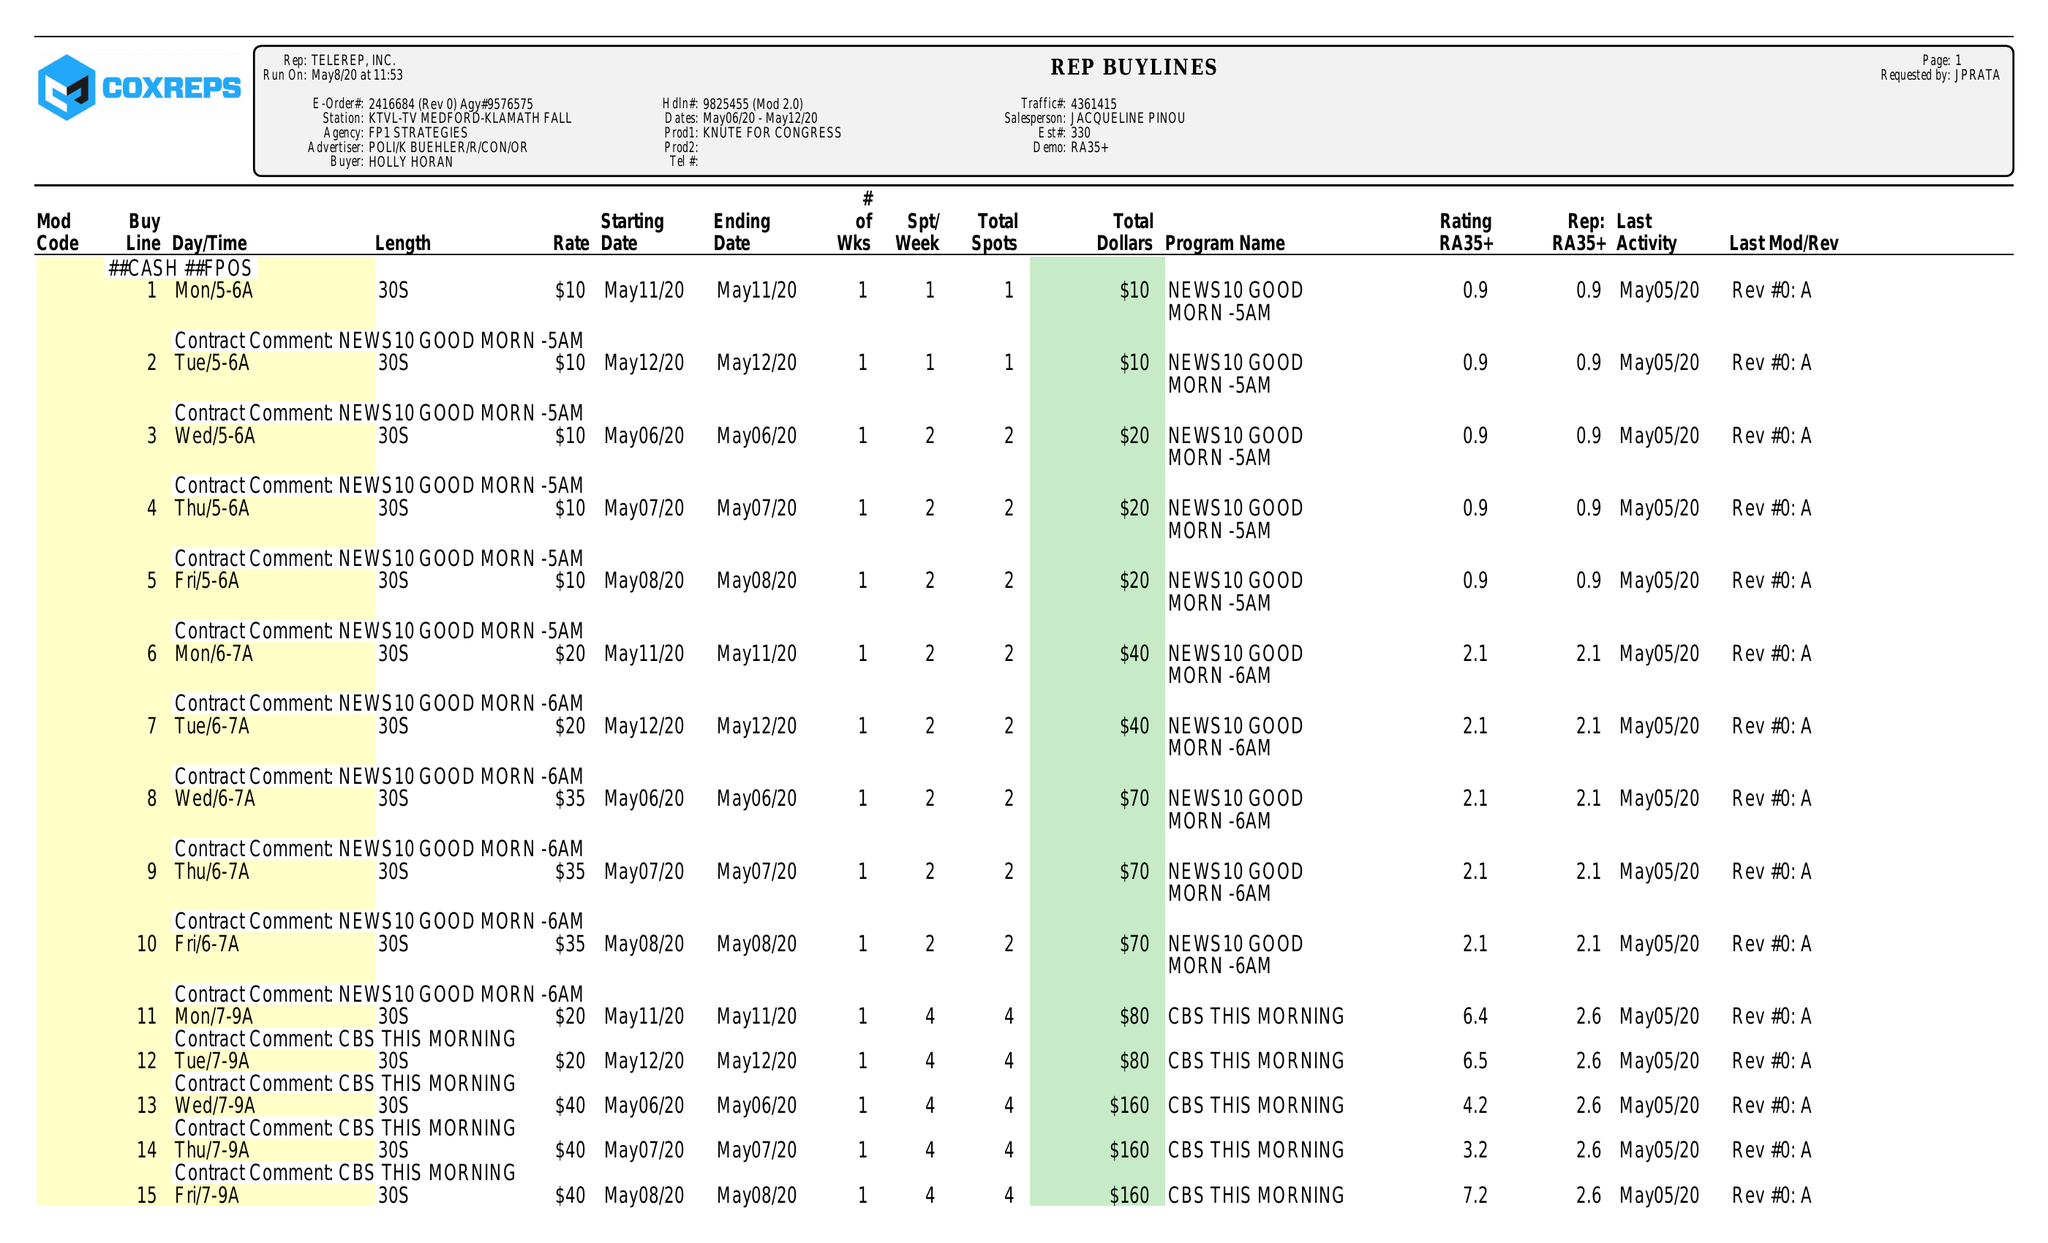What is the value for the flight_from?
Answer the question using a single word or phrase. 05/06/20 